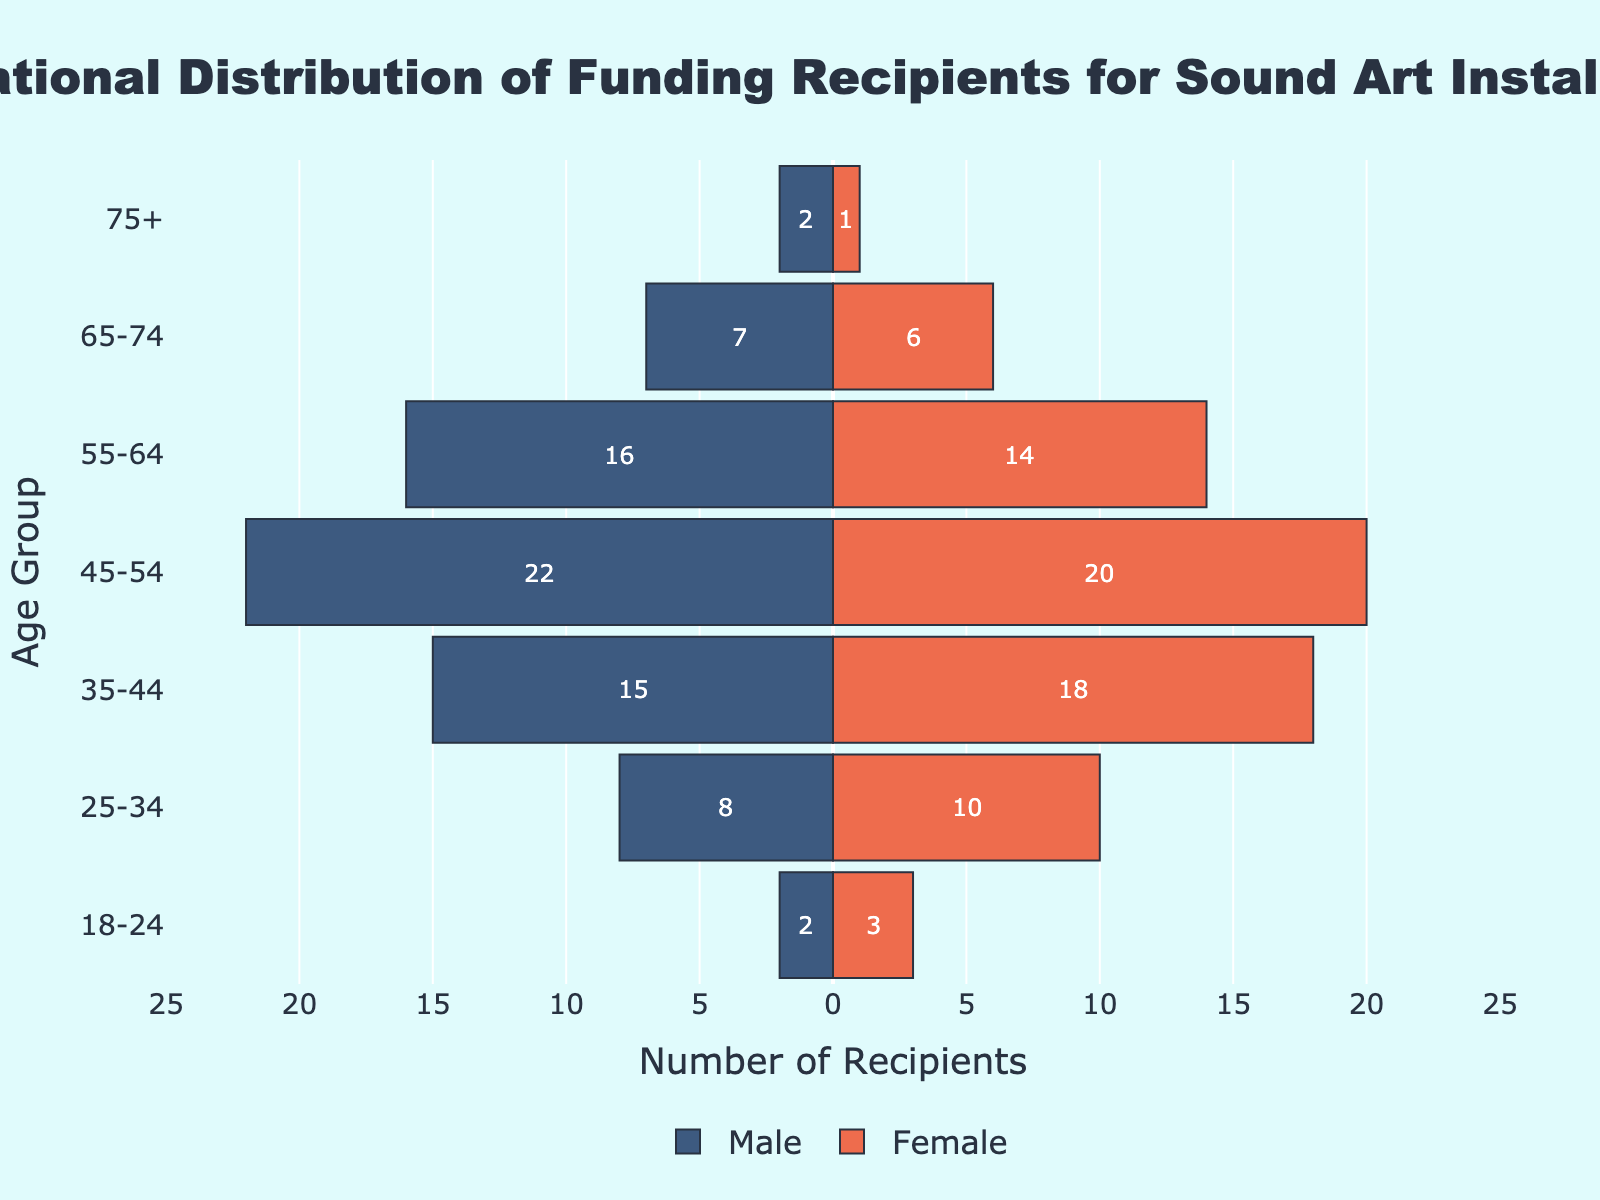What's the title of the figure? The title is typically located at the top of the figure and is meant to describe the main topic or data being visualized. In this figure, the title is prominently displayed in a large and bold font.
Answer: Generational Distribution of Funding Recipients for Sound Art Installations Which age group has the highest number of male recipients? Look for the group with the longest bar extending to the left, representing male recipients. The group with the highest number will have the longest bar.
Answer: 45-54 What's the total number of funding recipients in the 35-44 age group? Sum the male and female recipients in the 35-44 age group. The male value is 15, and the female value is 18. Therefore, the total number is 15 + 18.
Answer: 33 How many more male recipients are there in the 45-54 age group compared to the female recipients? Subtract the number of female recipients from the male recipients in the 45-54 age group. The male value is 22, and the female value is 20, so the difference is 22 - 20.
Answer: 2 Which age group has the smallest total number of recipients? Identify the age group with the shortest combined bars (both male and female). Check each group's total visually, or add the male and female values for each group and compare them.
Answer: 75+ What is the proportion of female recipients in the 55-64 age group? Divide the number of female recipients by the total number of recipients in the 55-64 age group. The female value is 14, and the total number of recipients is 16 (males) + 14 (females) = 30. The proportion is 14/30.
Answer: 0.47 Between the 25-34 and 65-74 age groups, which has a greater number of female recipients? Compare the lengths of the bars representing female recipients in the 25-34 and 65-74 age groups. The 25-34 group has 10 female recipients, and the 65-74 group has 6 female recipients.
Answer: 25-34 How does the number of recipients aged 18-24 compare to those aged 75+? Add the total values (male + female) for each age group and compare them. The 18-24 group has a total of 5 recipients (2 males + 3 females), and the 75+ group has 3 recipients (2 males + 1 female).
Answer: They are fairly close, with the 18-24 group having slightly more Is there any age group where female recipients outnumber male recipients? Compare the length of female and male bars for each age group. The 25-34 age group has more female recipients (10) compared to male recipients (8).
Answer: 25-34 What is the visual cue for determining the age group with the most balanced number of male and female recipients? Look for the age group where the lengths of the male and female bars are most similar. The 55-64 age group has male (16) and female (14) bars that are close in length.
Answer: 55-64 